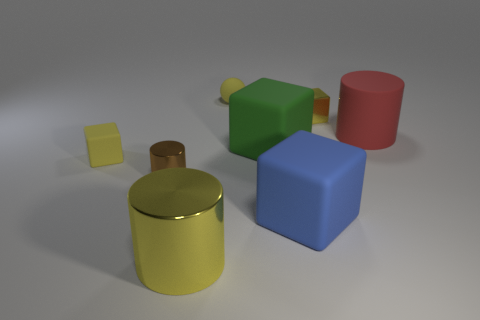Subtract all metallic blocks. How many blocks are left? 3 Add 2 tiny shiny blocks. How many objects exist? 10 Subtract all blue blocks. How many blocks are left? 3 Subtract all yellow spheres. How many yellow cubes are left? 2 Subtract 1 cubes. How many cubes are left? 3 Subtract all balls. How many objects are left? 7 Subtract all gray blocks. Subtract all yellow cylinders. How many blocks are left? 4 Subtract all small balls. Subtract all yellow shiny things. How many objects are left? 5 Add 8 green matte things. How many green matte things are left? 9 Add 2 yellow spheres. How many yellow spheres exist? 3 